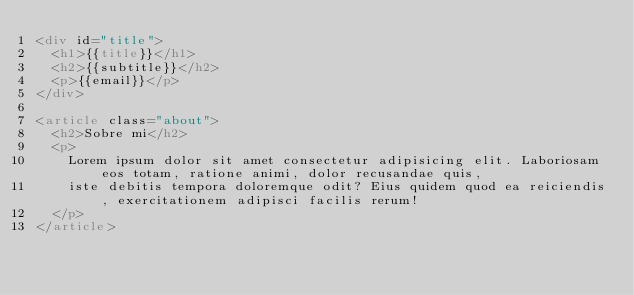<code> <loc_0><loc_0><loc_500><loc_500><_HTML_><div id="title">
  <h1>{{title}}</h1>
  <h2>{{subtitle}}</h2>
  <p>{{email}}</p>
</div>

<article class="about">
  <h2>Sobre mi</h2>
  <p>
    Lorem ipsum dolor sit amet consectetur adipisicing elit. Laboriosam eos totam, ratione animi, dolor recusandae quis,
    iste debitis tempora doloremque odit? Eius quidem quod ea reiciendis, exercitationem adipisci facilis rerum!
  </p>
</article></code> 